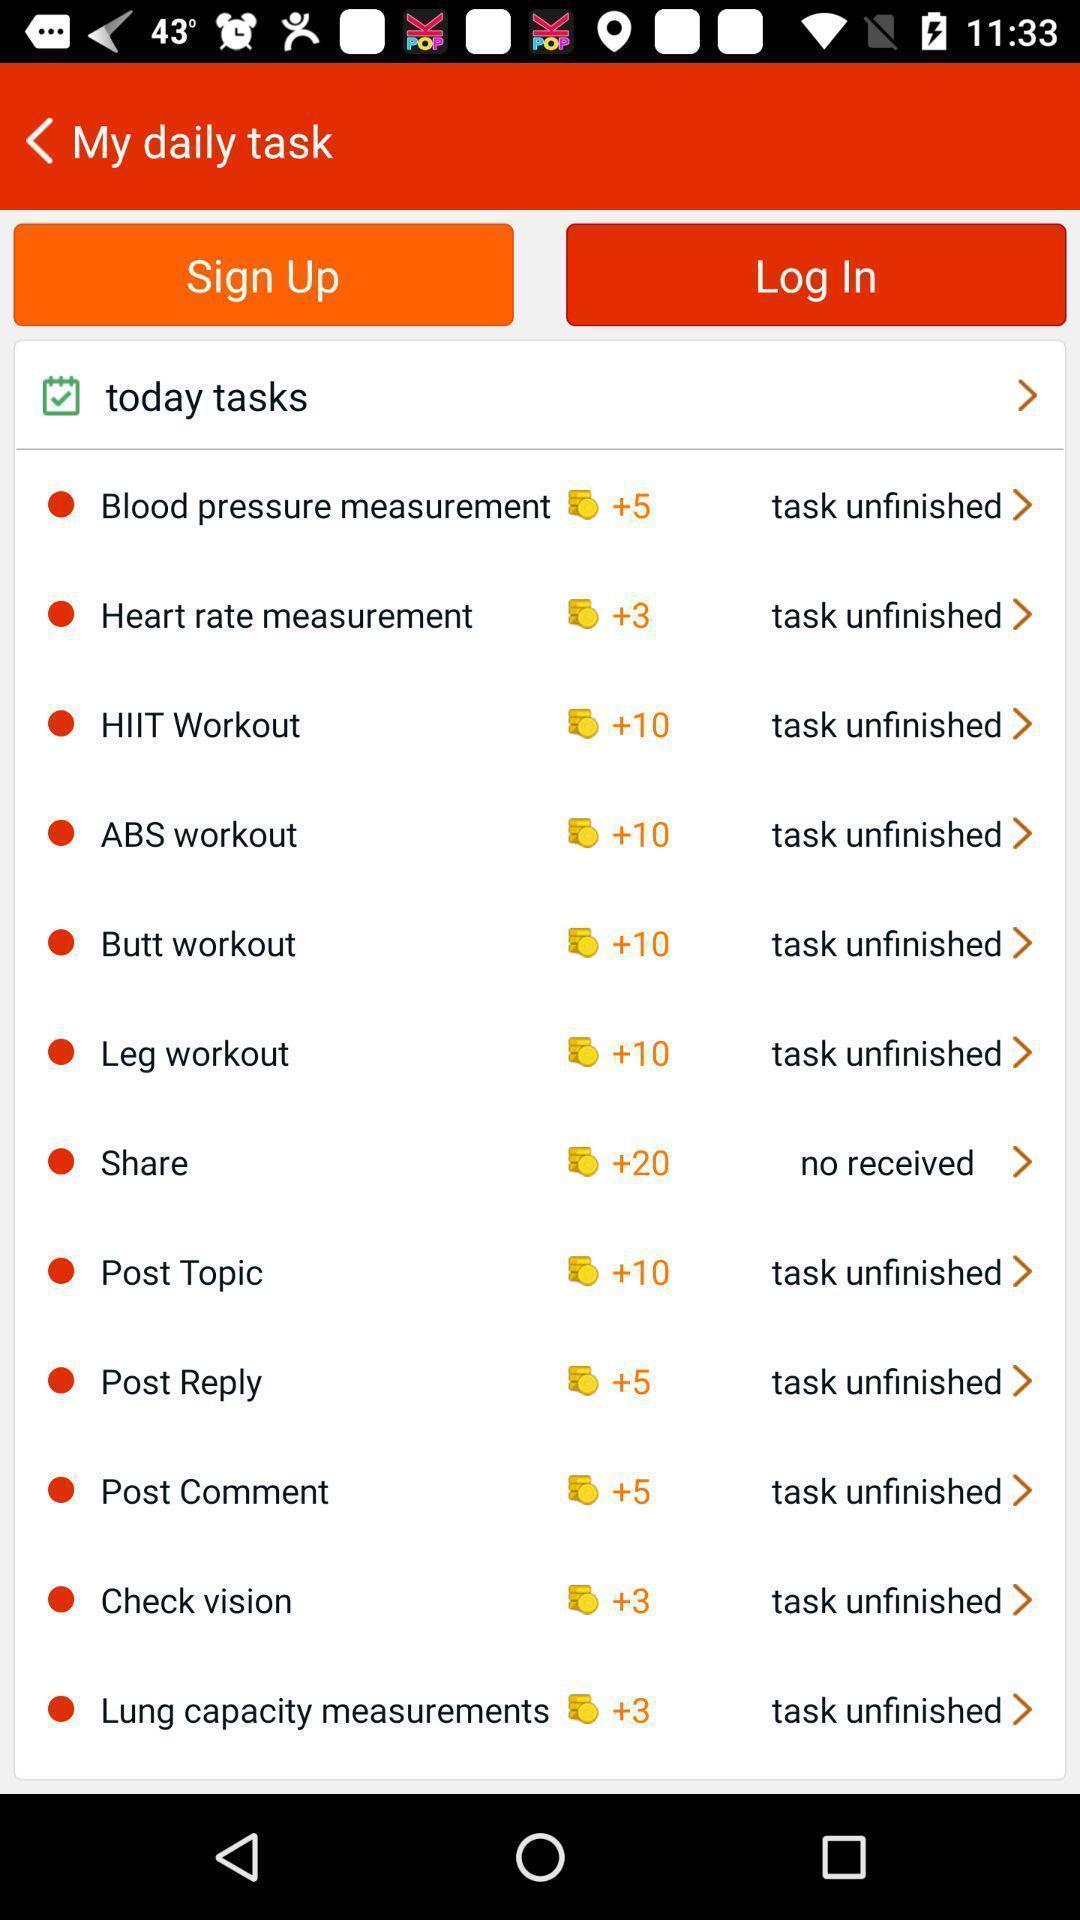Explain what's happening in this screen capture. Signup page with list of tasks in the health app. 